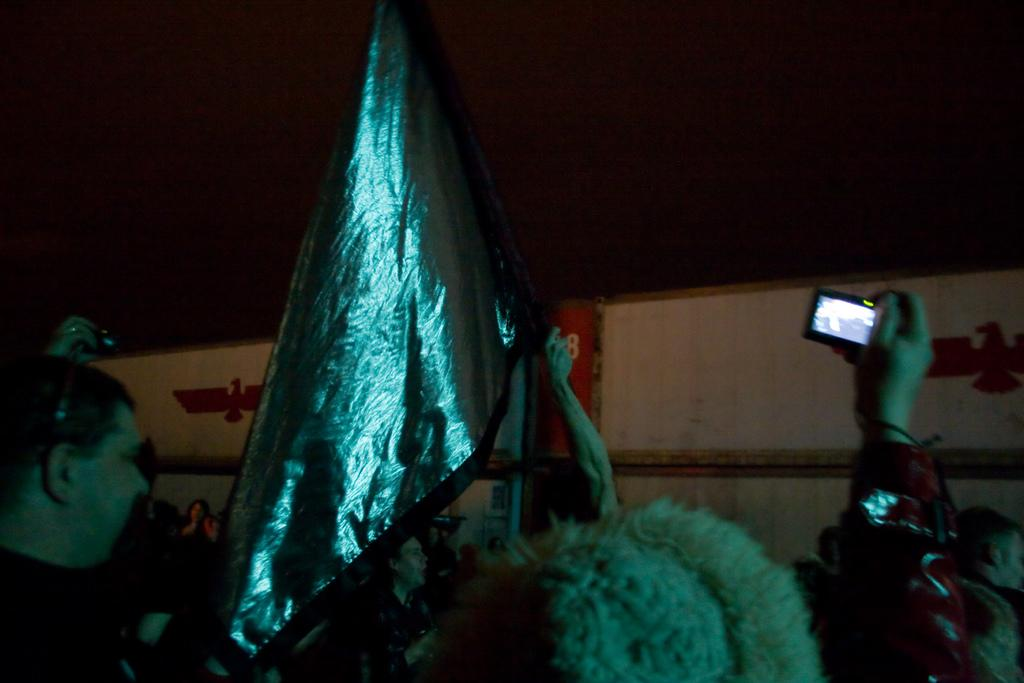What are the people in the image doing? The people in the image are standing. Can you describe the person on the right side of the image? The person on the right side of the image is holding a camera. What is in the middle of the image? There is a flag in the middle of the image. What is the color of the background in the image? The background of the image is dark. How many knots are tied in the flag in the image? There are no knots present in the flag in the image. What type of drink is being served in the image? There is no drink present in the image. 